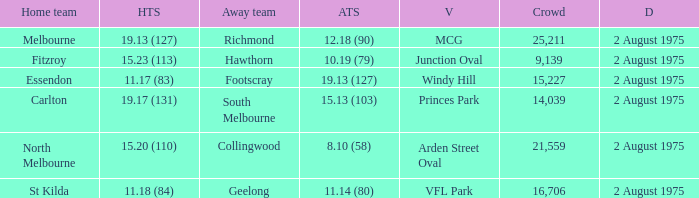What did the away team score when playing North Melbourne? 8.10 (58). 